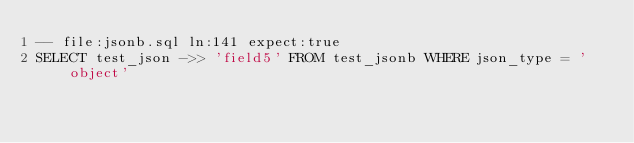Convert code to text. <code><loc_0><loc_0><loc_500><loc_500><_SQL_>-- file:jsonb.sql ln:141 expect:true
SELECT test_json ->> 'field5' FROM test_jsonb WHERE json_type = 'object'
</code> 